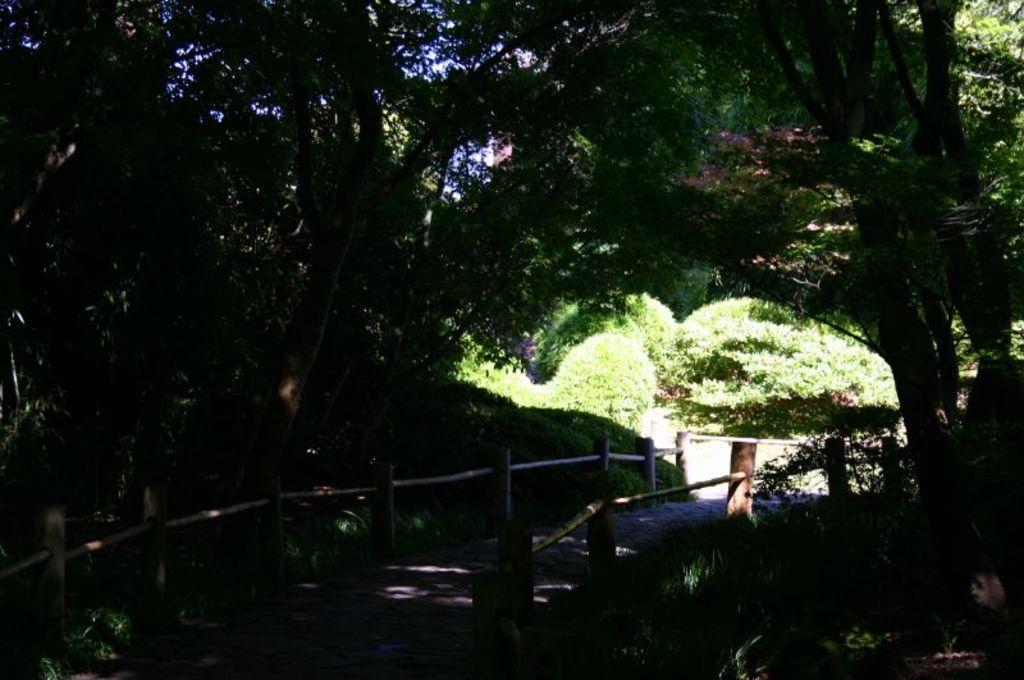In one or two sentences, can you explain what this image depicts? There is a road. On both sides of this road, there is wooden fencing. On the right side, there are trees and plants on the ground. In the background, there are trees, plants and there is sky. 